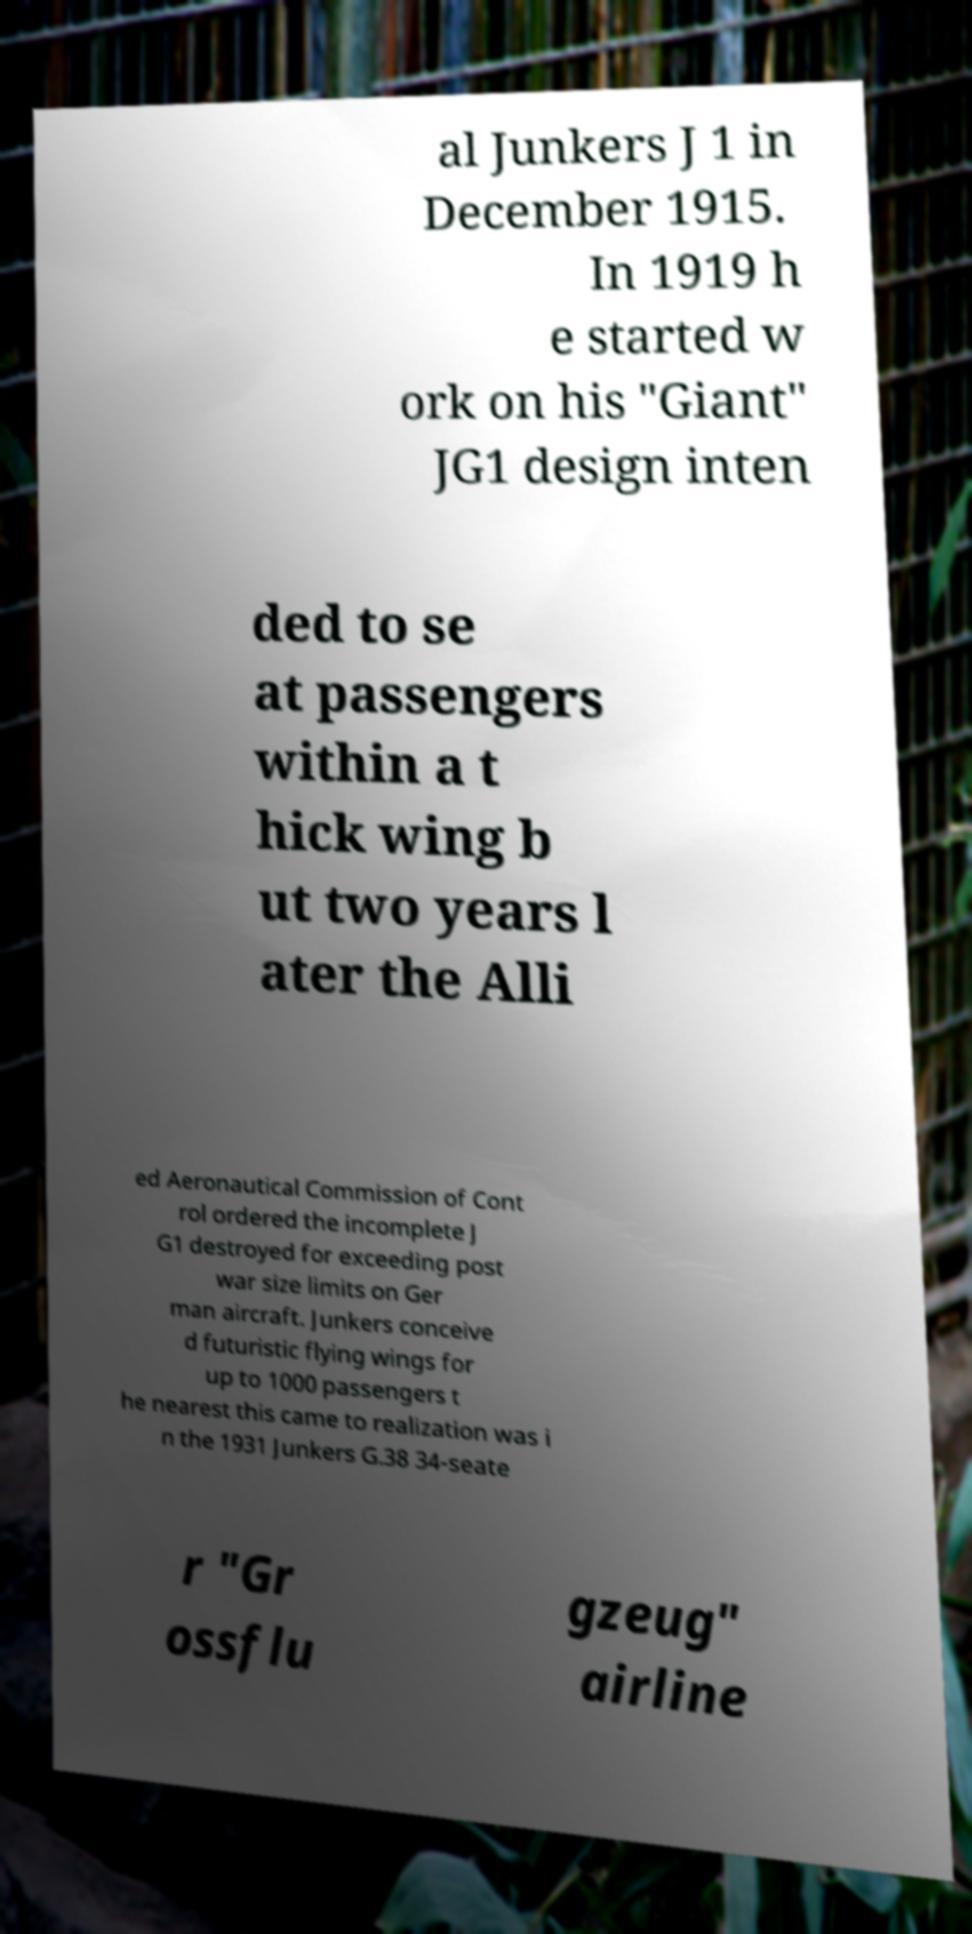There's text embedded in this image that I need extracted. Can you transcribe it verbatim? al Junkers J 1 in December 1915. In 1919 h e started w ork on his "Giant" JG1 design inten ded to se at passengers within a t hick wing b ut two years l ater the Alli ed Aeronautical Commission of Cont rol ordered the incomplete J G1 destroyed for exceeding post war size limits on Ger man aircraft. Junkers conceive d futuristic flying wings for up to 1000 passengers t he nearest this came to realization was i n the 1931 Junkers G.38 34-seate r "Gr ossflu gzeug" airline 